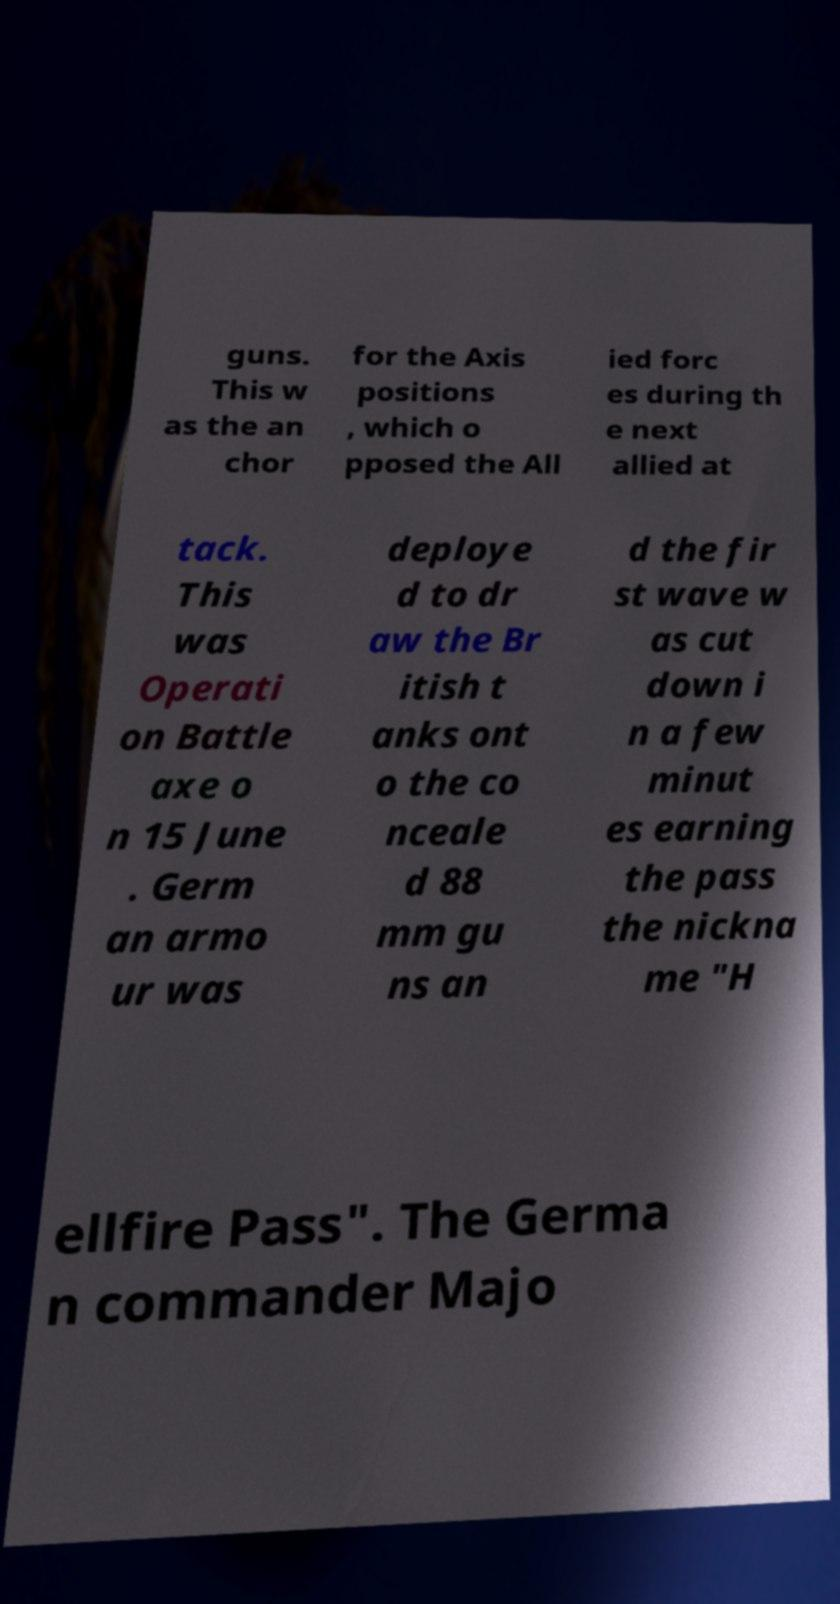What messages or text are displayed in this image? I need them in a readable, typed format. guns. This w as the an chor for the Axis positions , which o pposed the All ied forc es during th e next allied at tack. This was Operati on Battle axe o n 15 June . Germ an armo ur was deploye d to dr aw the Br itish t anks ont o the co nceale d 88 mm gu ns an d the fir st wave w as cut down i n a few minut es earning the pass the nickna me "H ellfire Pass". The Germa n commander Majo 